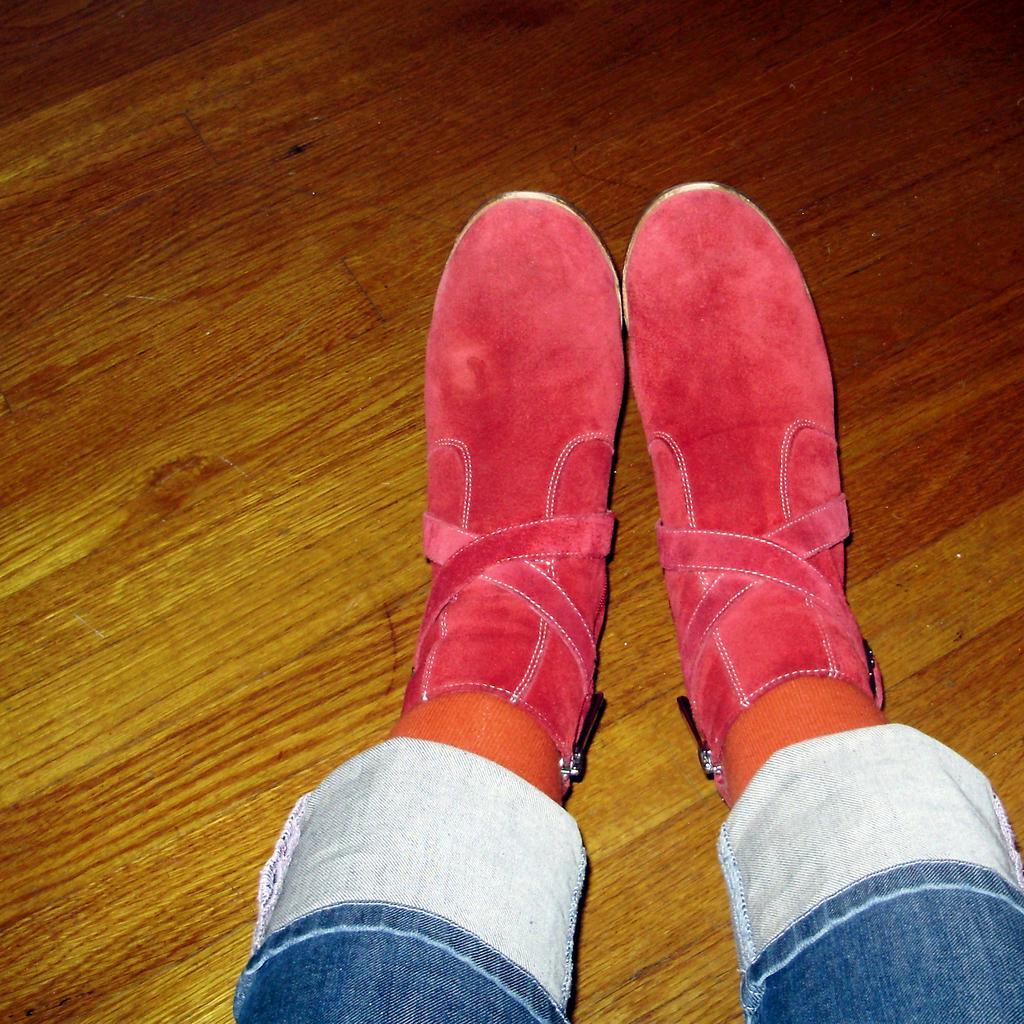Can you describe this image briefly? In this image there are legs of a person wearing footwear on the floor. 